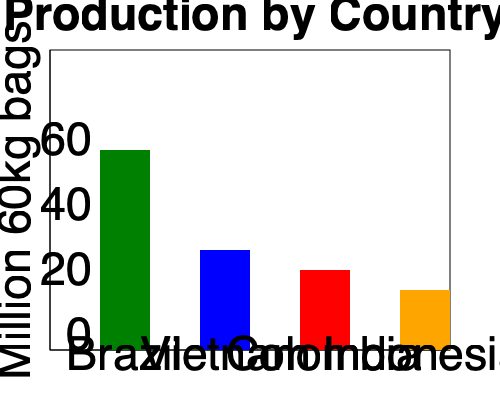Based on the bar graph showing coffee production in 2021, approximately how many more million 60kg bags of coffee did Brazil produce compared to Vietnam? To find the difference in coffee production between Brazil and Vietnam, we need to:

1. Identify Brazil's production:
   - Brazil's bar reaches the 60 million bag mark
   - Therefore, Brazil produced 60 million 60kg bags

2. Identify Vietnam's production:
   - Vietnam's bar reaches halfway between the 20 and 40 million bag marks
   - This indicates Vietnam produced approximately 30 million 60kg bags

3. Calculate the difference:
   $60 \text{ million} - 30 \text{ million} = 30 \text{ million}$

Therefore, Brazil produced approximately 30 million more 60kg bags of coffee than Vietnam in 2021.
Answer: 30 million 60kg bags 